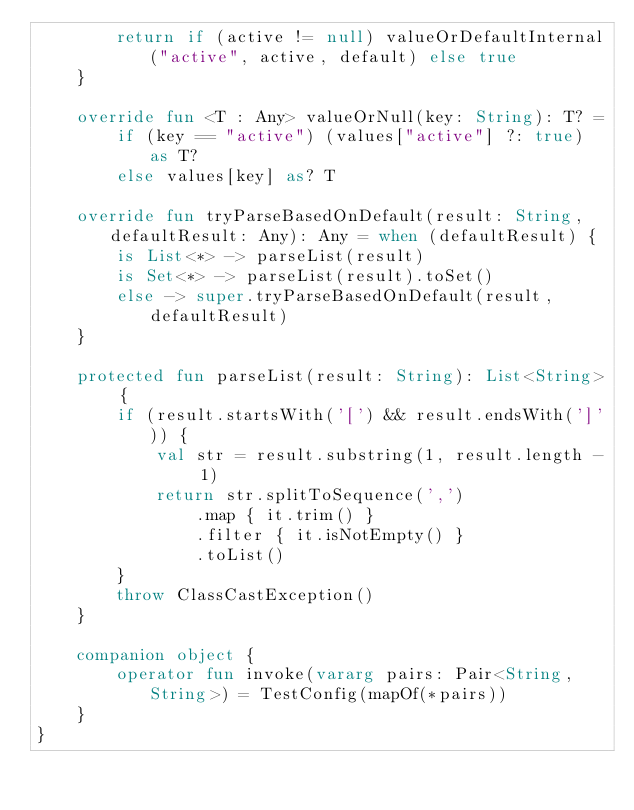Convert code to text. <code><loc_0><loc_0><loc_500><loc_500><_Kotlin_>        return if (active != null) valueOrDefaultInternal("active", active, default) else true
    }

    override fun <T : Any> valueOrNull(key: String): T? =
        if (key == "active") (values["active"] ?: true) as T?
        else values[key] as? T

    override fun tryParseBasedOnDefault(result: String, defaultResult: Any): Any = when (defaultResult) {
        is List<*> -> parseList(result)
        is Set<*> -> parseList(result).toSet()
        else -> super.tryParseBasedOnDefault(result, defaultResult)
    }

    protected fun parseList(result: String): List<String> {
        if (result.startsWith('[') && result.endsWith(']')) {
            val str = result.substring(1, result.length - 1)
            return str.splitToSequence(',')
                .map { it.trim() }
                .filter { it.isNotEmpty() }
                .toList()
        }
        throw ClassCastException()
    }

    companion object {
        operator fun invoke(vararg pairs: Pair<String, String>) = TestConfig(mapOf(*pairs))
    }
}
</code> 